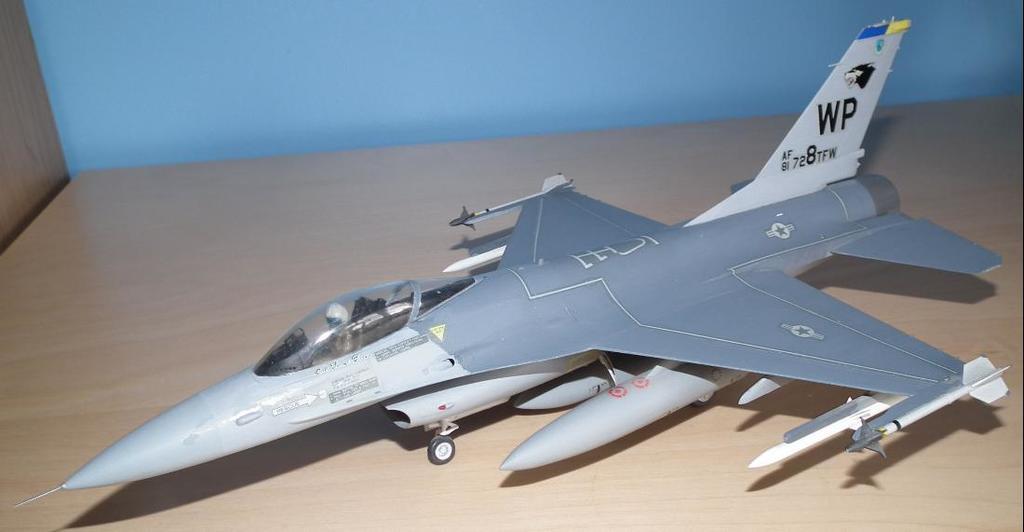What is the plane name?
Offer a terse response. Wp. What is the plane number?
Offer a terse response. 728tfw. 